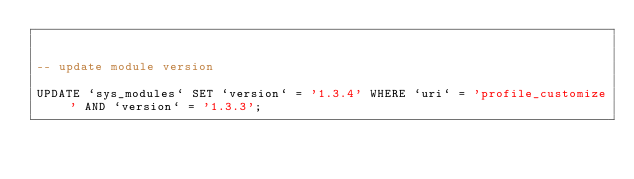<code> <loc_0><loc_0><loc_500><loc_500><_SQL_>

-- update module version

UPDATE `sys_modules` SET `version` = '1.3.4' WHERE `uri` = 'profile_customize' AND `version` = '1.3.3';

</code> 